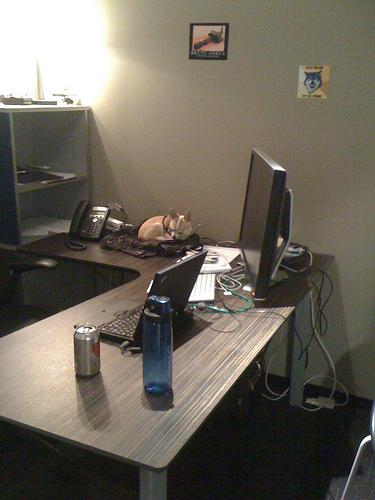Question: when would you use the telephone?
Choices:
A. When you need to make a call.
B. To hear some heavy breathing.
C. Because you like listening to the dial tone.
D. Because some called you.
Answer with the letter. Answer: A Question: why is the computer off?
Choices:
A. The power went out.
B. It crashed.
C. It got a virus.
D. No one is using it.
Answer with the letter. Answer: D Question: what color is the table?
Choices:
A. White.
B. Black.
C. Gray.
D. Brown.
Answer with the letter. Answer: D 